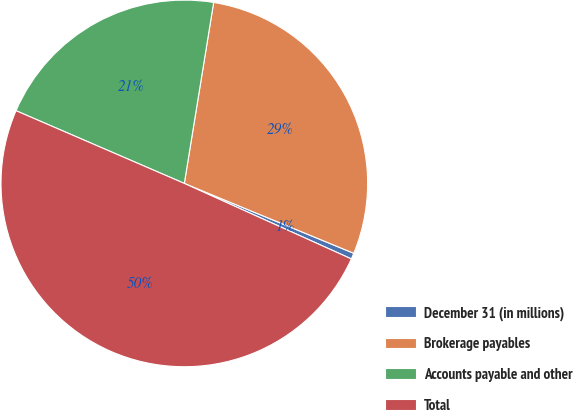Convert chart. <chart><loc_0><loc_0><loc_500><loc_500><pie_chart><fcel>December 31 (in millions)<fcel>Brokerage payables<fcel>Accounts payable and other<fcel>Total<nl><fcel>0.53%<fcel>28.67%<fcel>21.07%<fcel>49.74%<nl></chart> 